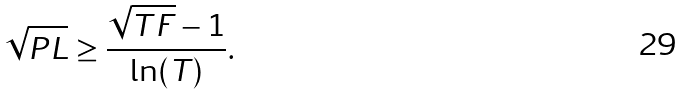Convert formula to latex. <formula><loc_0><loc_0><loc_500><loc_500>\sqrt { P L } \geq \frac { \sqrt { T F } - 1 } { \ln ( T ) } .</formula> 